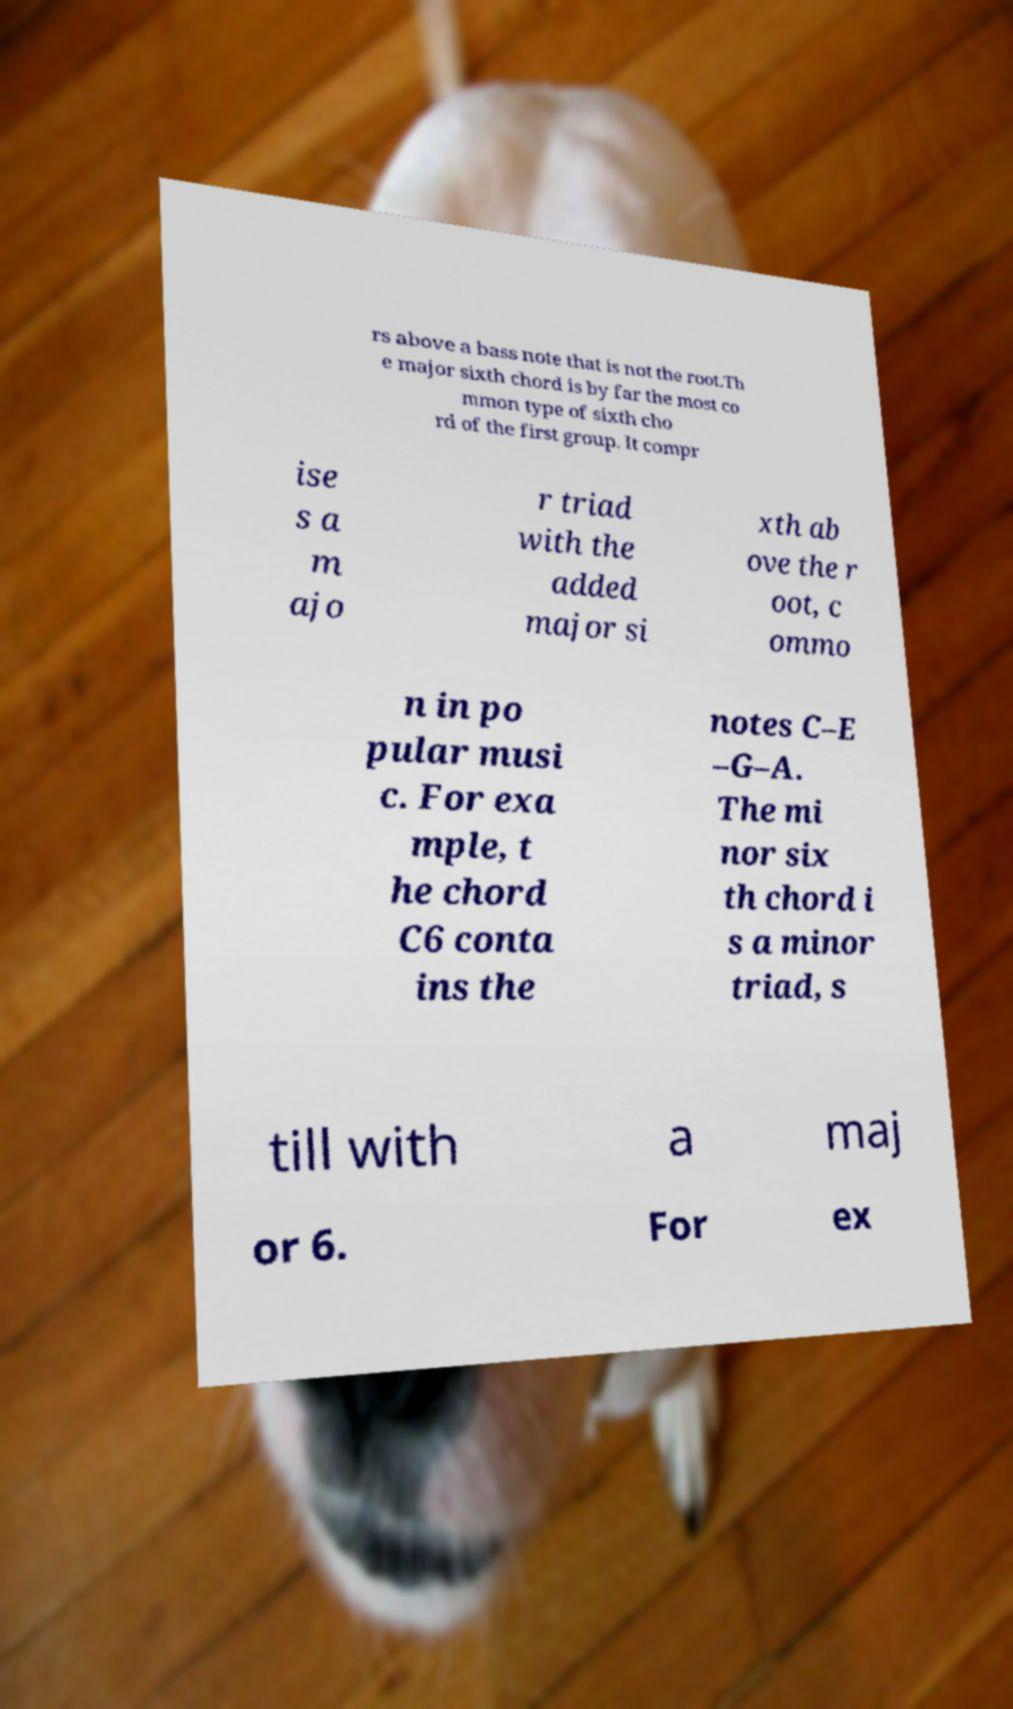For documentation purposes, I need the text within this image transcribed. Could you provide that? rs above a bass note that is not the root.Th e major sixth chord is by far the most co mmon type of sixth cho rd of the first group. It compr ise s a m ajo r triad with the added major si xth ab ove the r oot, c ommo n in po pular musi c. For exa mple, t he chord C6 conta ins the notes C–E –G–A. The mi nor six th chord i s a minor triad, s till with a maj or 6. For ex 